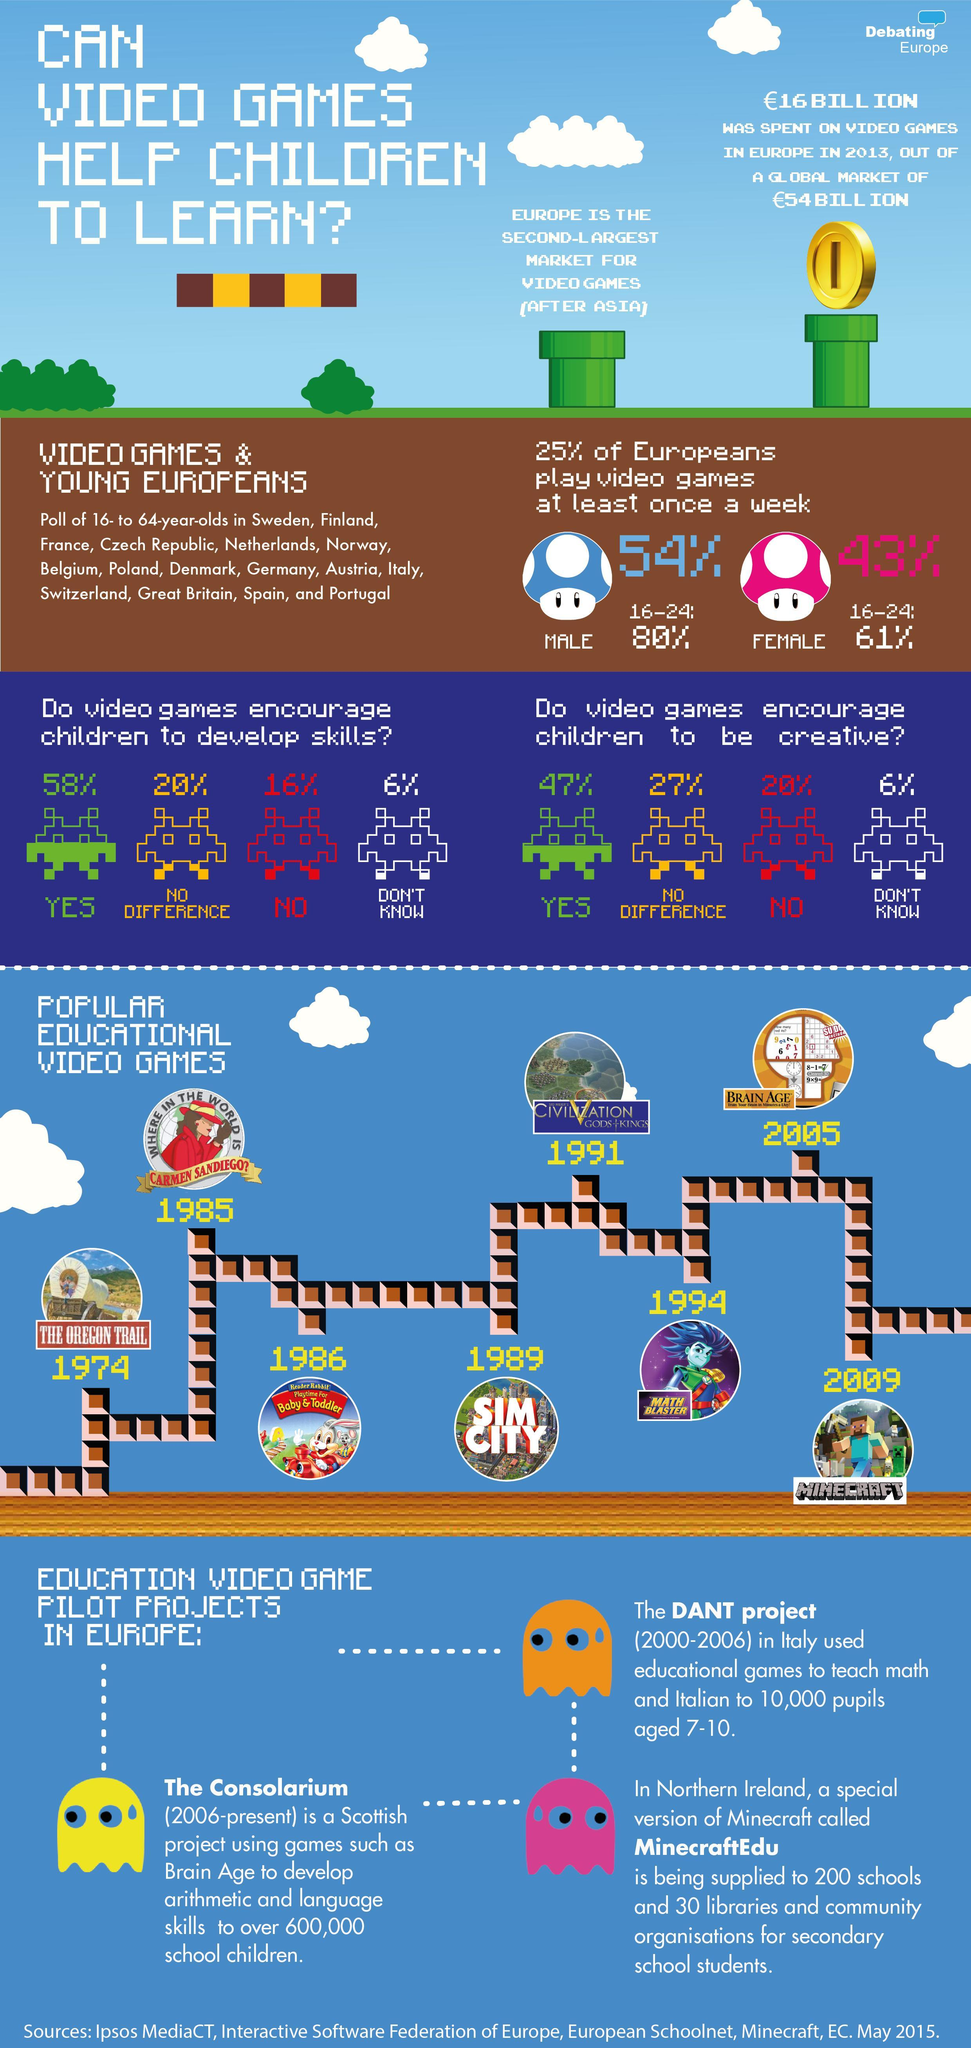When was SIM CITY introduced
Answer the question with a short phrase. 1989 Which continent is the largest market for video games Asia How many think that video games do not encourage creative skills 20% Among the Europeans who play video games, what is the male share 54% What is the global spent in billion euros on video games in 2013, after removing the share of Europe 38 Among the Europeans who play video games, what is the female share 43% How many years after SIM CIty was Math Blaster introduced 5 